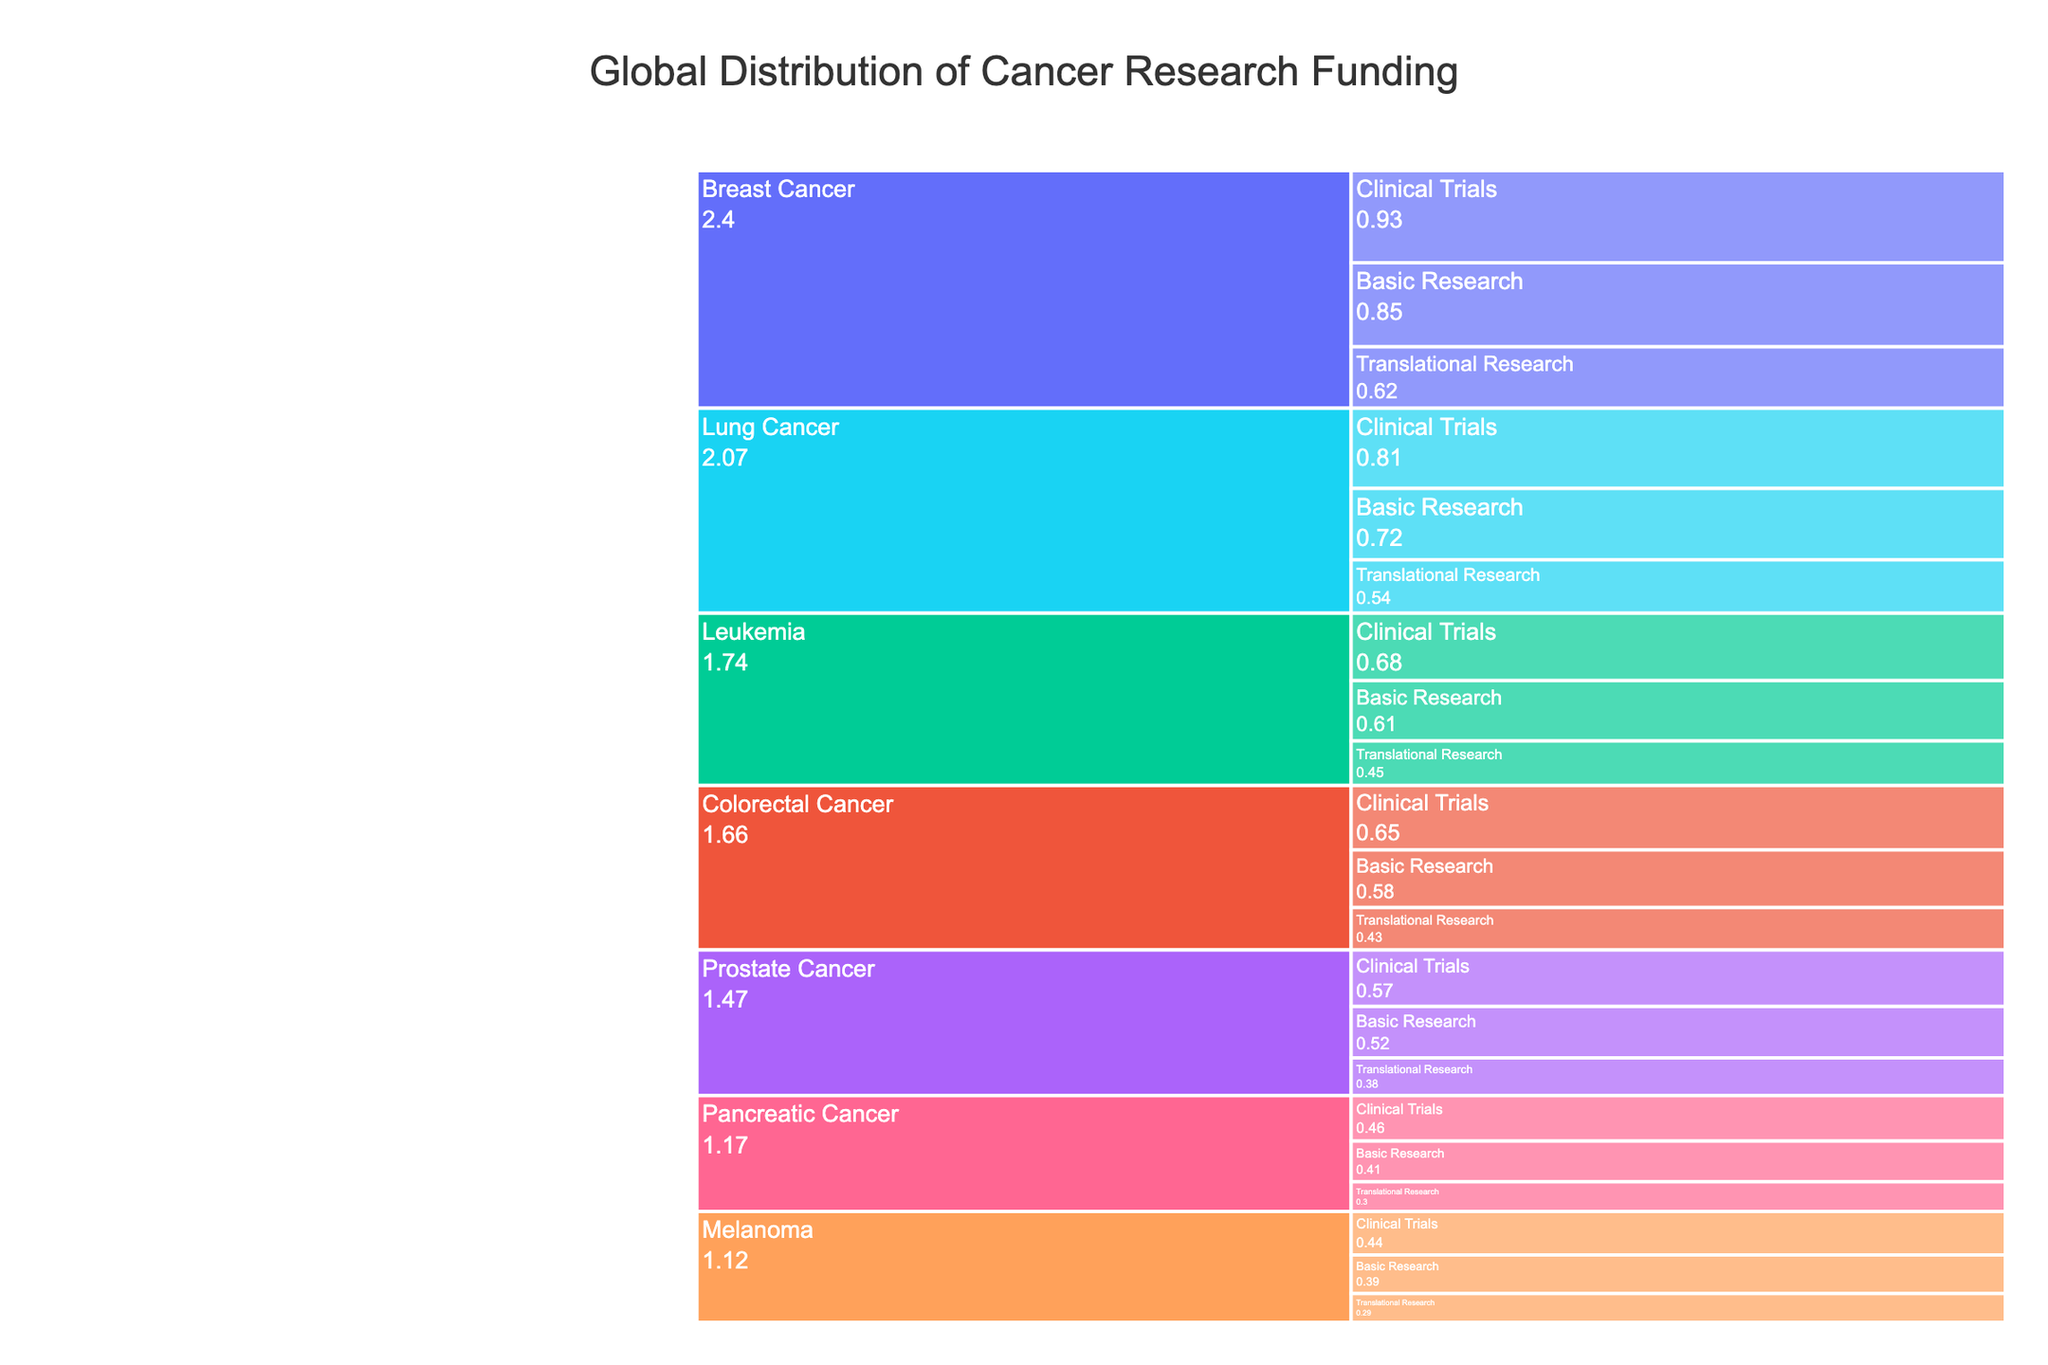How much funding is allocated to basic research for Lung Cancer? To find the funding allocated to basic research for Lung Cancer, we can look at the section labeled "Lung Cancer" and within that, identify the "Basic Research" subsection. The funding amount provided is in millions of USD.
Answer: 720 million USD Which cancer type receives the highest total funding across all research phases? Sum the funding amounts across all research phases for each cancer type to identify the highest total. Breast Cancer has 850 (Basic) + 620 (Translational) + 930 (Clinical) = 2400 million USD, which is the highest.
Answer: Breast Cancer What is the difference in funding between Basic Research and Clinical Trials for Prostate Cancer? Identify the funding for Basic Research (520 million USD) and Clinical Trials (570 million USD) for Prostate Cancer from the chart. Calculate the difference as 570 - 520.
Answer: 50 million USD Which research phase receives the most funding for Colorectal Cancer? Compare the funding amounts for Basic Research (580 million USD), Translational Research (430 million USD), and Clinical Trials (650 million USD) within Colorectal Cancer. Clinical Trials has the highest amount.
Answer: Clinical Trials How much total funding is allocated to Melanoma research across all phases? Sum the funding amounts for all research phases of Melanoma: 390 (Basic) + 290 (Translational) + 440 (Clinical). The total is 1120 million USD.
Answer: 1120 million USD Which cancer type has the smallest difference in funding between Translational Research and Basic Research? Calculate the differences for each cancer type and identify the smallest one. For Melanoma, the difference is 290 - 390 = 100 million USD. Repeat this for each cancer type and find the minimum difference. Melanoma has the smallest difference.
Answer: Melanoma Which research phase receives the least total funding across all cancer types? Sum up the funding for each research phase across all cancer types. Basic Research: 850+720+580+610+520+390+410 = 4080 million USD, Translational Research: 620+540+430+450+380+290+300 = 3010 million USD, Clinical Trials: 930+810+650+680+570+440+460 = 4540 million USD. Translational Research receives the least total funding.
Answer: Translational Research How does funding for Translational Research in Pancreatic Cancer compare to that in Lung Cancer? Identify funding for Translational Research in Pancreatic Cancer (300 million USD) and in Lung Cancer (540 million USD) from the chart. Pancreatic Cancer has less funding.
Answer: Pancreatic Cancer has less funding What is the funding amount for Clinical Trials on Leukemia? Locate the Clinical Trials section within Leukemia and identify the funding amount. The funding for Clinical Trials on Leukemia is 680 million USD.
Answer: 680 million USD Between Breast Cancer and Lung Cancer, which one has higher funding for Clinical Trials? Compare the Clinical Trials funding amounts for Breast Cancer (930 million USD) and Lung Cancer (810 million USD). Breast Cancer has higher funding.
Answer: Breast Cancer 